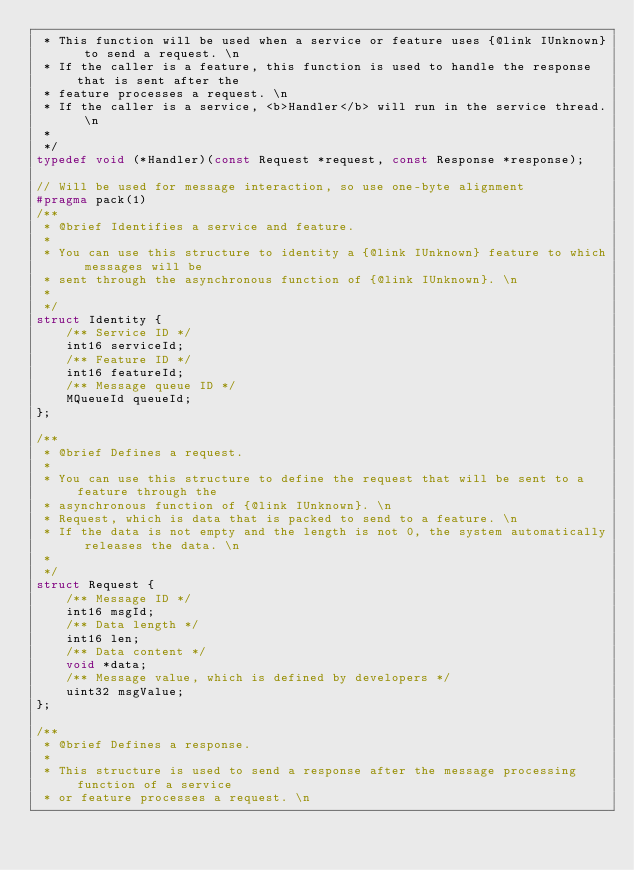<code> <loc_0><loc_0><loc_500><loc_500><_C_> * This function will be used when a service or feature uses {@link IUnknown} to send a request. \n
 * If the caller is a feature, this function is used to handle the response that is sent after the
 * feature processes a request. \n
 * If the caller is a service, <b>Handler</b> will run in the service thread. \n
 *
 */
typedef void (*Handler)(const Request *request, const Response *response);

// Will be used for message interaction, so use one-byte alignment
#pragma pack(1)
/**
 * @brief Identifies a service and feature.
 *
 * You can use this structure to identity a {@link IUnknown} feature to which messages will be
 * sent through the asynchronous function of {@link IUnknown}. \n
 *
 */
struct Identity {
    /** Service ID */
    int16 serviceId;
    /** Feature ID */
    int16 featureId;
    /** Message queue ID */
    MQueueId queueId;
};

/**
 * @brief Defines a request.
 *
 * You can use this structure to define the request that will be sent to a feature through the
 * asynchronous function of {@link IUnknown}. \n
 * Request, which is data that is packed to send to a feature. \n
 * If the data is not empty and the length is not 0, the system automatically releases the data. \n
 *
 */
struct Request {
    /** Message ID */
    int16 msgId;
    /** Data length */
    int16 len;
    /** Data content */
    void *data;
    /** Message value, which is defined by developers */
    uint32 msgValue;
};

/**
 * @brief Defines a response.
 *
 * This structure is used to send a response after the message processing function of a service
 * or feature processes a request. \n</code> 